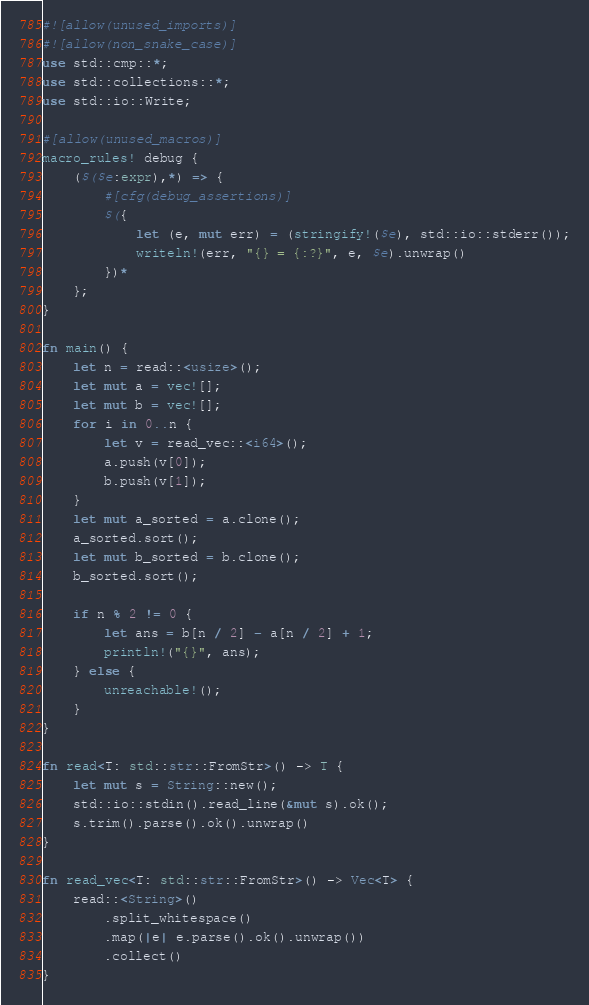Convert code to text. <code><loc_0><loc_0><loc_500><loc_500><_Rust_>#![allow(unused_imports)]
#![allow(non_snake_case)]
use std::cmp::*;
use std::collections::*;
use std::io::Write;

#[allow(unused_macros)]
macro_rules! debug {
    ($($e:expr),*) => {
        #[cfg(debug_assertions)]
        $({
            let (e, mut err) = (stringify!($e), std::io::stderr());
            writeln!(err, "{} = {:?}", e, $e).unwrap()
        })*
    };
}

fn main() {
    let n = read::<usize>();
    let mut a = vec![];
    let mut b = vec![];
    for i in 0..n {
        let v = read_vec::<i64>();
        a.push(v[0]);
        b.push(v[1]);
    }
    let mut a_sorted = a.clone();
    a_sorted.sort();
    let mut b_sorted = b.clone();
    b_sorted.sort();

    if n % 2 != 0 {
        let ans = b[n / 2] - a[n / 2] + 1;
        println!("{}", ans);
    } else {
        unreachable!();
    }
}

fn read<T: std::str::FromStr>() -> T {
    let mut s = String::new();
    std::io::stdin().read_line(&mut s).ok();
    s.trim().parse().ok().unwrap()
}

fn read_vec<T: std::str::FromStr>() -> Vec<T> {
    read::<String>()
        .split_whitespace()
        .map(|e| e.parse().ok().unwrap())
        .collect()
}
</code> 